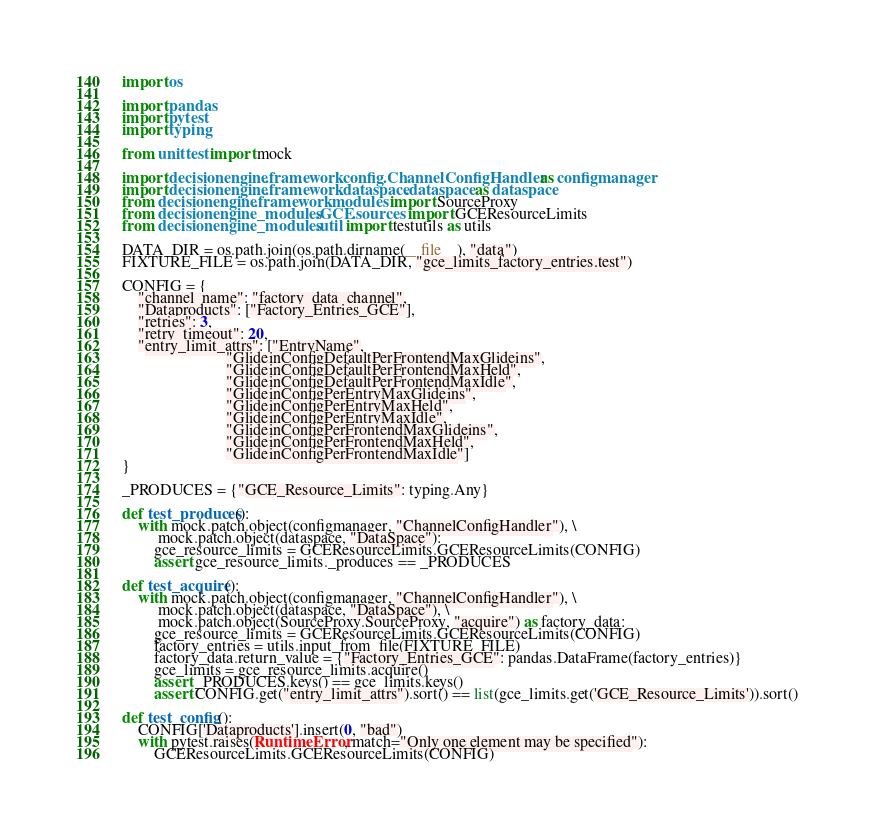<code> <loc_0><loc_0><loc_500><loc_500><_Python_>import os

import pandas
import pytest
import typing

from unittest import mock

import decisionengine.framework.config.ChannelConfigHandler as configmanager
import decisionengine.framework.dataspace.dataspace as dataspace
from decisionengine.framework.modules import SourceProxy
from decisionengine_modules.GCE.sources import GCEResourceLimits
from decisionengine_modules.util import testutils as utils

DATA_DIR = os.path.join(os.path.dirname(__file__), "data")
FIXTURE_FILE = os.path.join(DATA_DIR, "gce_limits_factory_entries.test")

CONFIG = {
    "channel_name": "factory_data_channel",
    "Dataproducts": ["Factory_Entries_GCE"],
    "retries": 3,
    "retry_timeout": 20,
    "entry_limit_attrs": ["EntryName",
                          "GlideinConfigDefaultPerFrontendMaxGlideins",
                          "GlideinConfigDefaultPerFrontendMaxHeld",
                          "GlideinConfigDefaultPerFrontendMaxIdle",
                          "GlideinConfigPerEntryMaxGlideins",
                          "GlideinConfigPerEntryMaxHeld",
                          "GlideinConfigPerEntryMaxIdle",
                          "GlideinConfigPerFrontendMaxGlideins",
                          "GlideinConfigPerFrontendMaxHeld",
                          "GlideinConfigPerFrontendMaxIdle"]
}

_PRODUCES = {"GCE_Resource_Limits": typing.Any}

def test_produces():
    with mock.patch.object(configmanager, "ChannelConfigHandler"), \
         mock.patch.object(dataspace, "DataSpace"):
        gce_resource_limits = GCEResourceLimits.GCEResourceLimits(CONFIG)
        assert gce_resource_limits._produces == _PRODUCES

def test_acquire():
    with mock.patch.object(configmanager, "ChannelConfigHandler"), \
         mock.patch.object(dataspace, "DataSpace"), \
         mock.patch.object(SourceProxy.SourceProxy, "acquire") as factory_data:
        gce_resource_limits = GCEResourceLimits.GCEResourceLimits(CONFIG)
        factory_entries = utils.input_from_file(FIXTURE_FILE)
        factory_data.return_value = {"Factory_Entries_GCE": pandas.DataFrame(factory_entries)}
        gce_limits = gce_resource_limits.acquire()
        assert _PRODUCES.keys() == gce_limits.keys()
        assert CONFIG.get("entry_limit_attrs").sort() == list(gce_limits.get('GCE_Resource_Limits')).sort()

def test_config():
    CONFIG['Dataproducts'].insert(0, "bad")
    with pytest.raises(RuntimeError, match="Only one element may be specified"):
        GCEResourceLimits.GCEResourceLimits(CONFIG)
</code> 